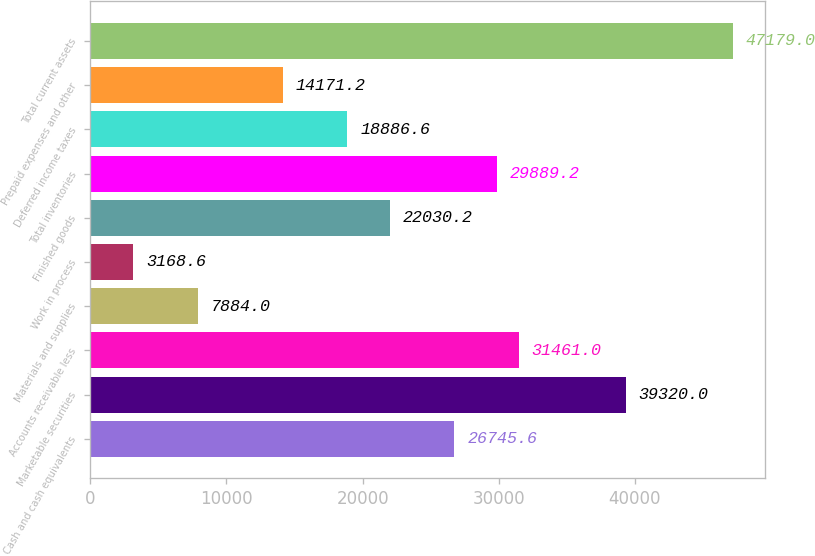<chart> <loc_0><loc_0><loc_500><loc_500><bar_chart><fcel>Cash and cash equivalents<fcel>Marketable securities<fcel>Accounts receivable less<fcel>Materials and supplies<fcel>Work in process<fcel>Finished goods<fcel>Total inventories<fcel>Deferred income taxes<fcel>Prepaid expenses and other<fcel>Total current assets<nl><fcel>26745.6<fcel>39320<fcel>31461<fcel>7884<fcel>3168.6<fcel>22030.2<fcel>29889.2<fcel>18886.6<fcel>14171.2<fcel>47179<nl></chart> 